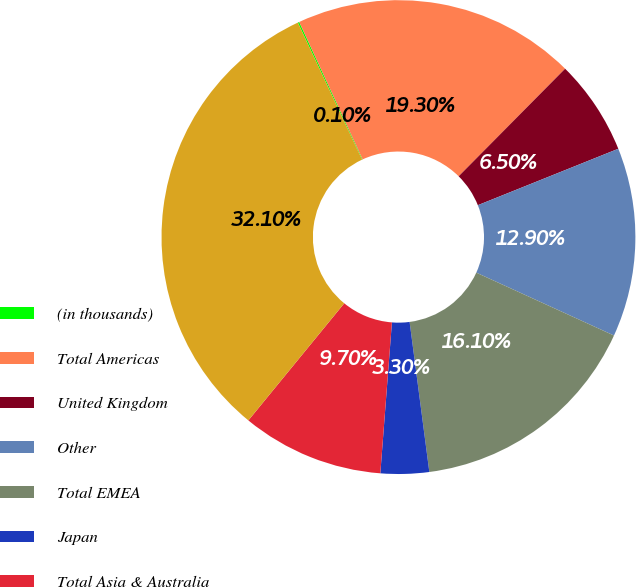Convert chart. <chart><loc_0><loc_0><loc_500><loc_500><pie_chart><fcel>(in thousands)<fcel>Total Americas<fcel>United Kingdom<fcel>Other<fcel>Total EMEA<fcel>Japan<fcel>Total Asia & Australia<fcel>Total<nl><fcel>0.1%<fcel>19.3%<fcel>6.5%<fcel>12.9%<fcel>16.1%<fcel>3.3%<fcel>9.7%<fcel>32.1%<nl></chart> 